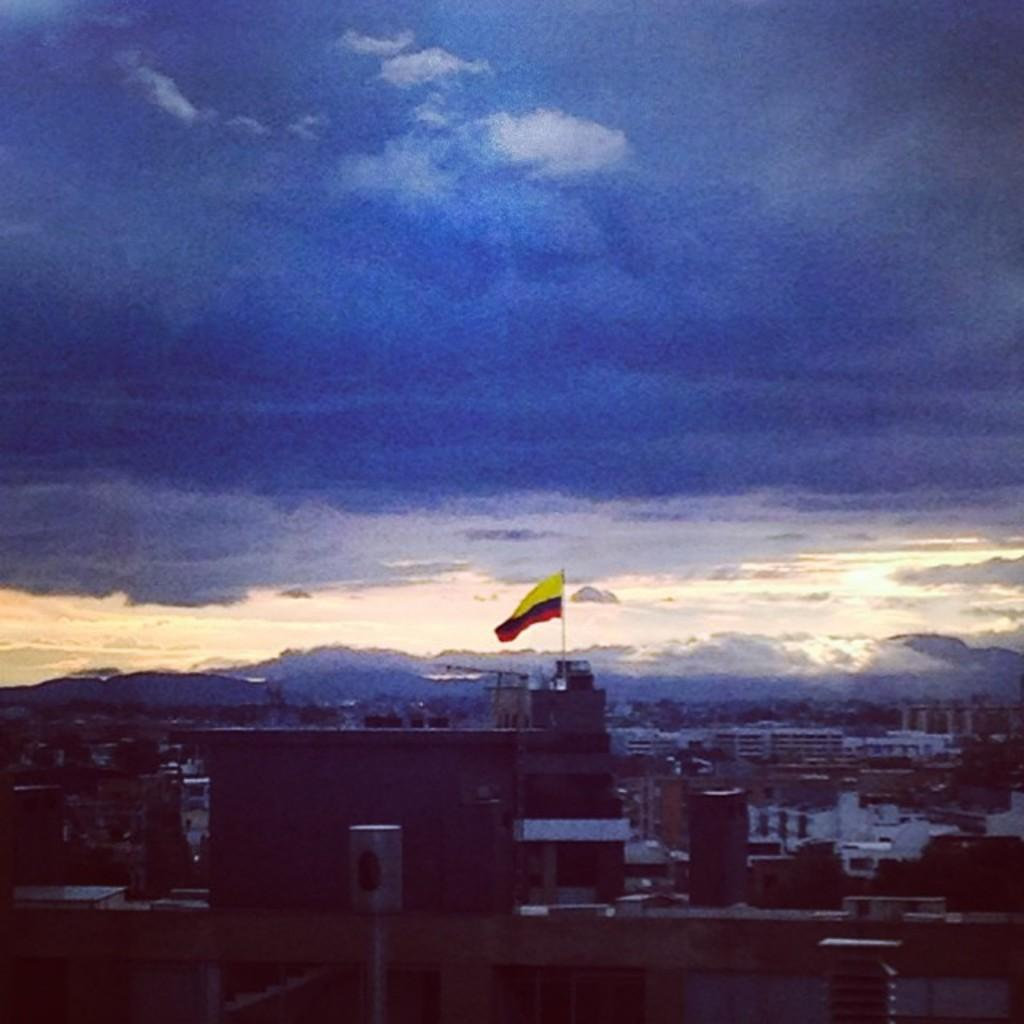What is the main subject in the center of the image? There is a building and a flag in the center of the image. Can you describe the building at the bottom of the image? There is a building at the bottom of the image. What can be seen in the background of the image? There are buildings, trees, hills, the sky, and clouds visible in the background of the image. What color is the crayon used to draw the skin of the tongue in the image? There is no tongue or crayon present in the image. What type of skin is visible on the buildings in the image? The buildings in the image are made of materials such as brick, concrete, or glass, and do not have skin. 